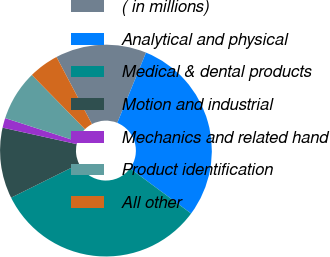Convert chart to OTSL. <chart><loc_0><loc_0><loc_500><loc_500><pie_chart><fcel>( in millions)<fcel>Analytical and physical<fcel>Medical & dental products<fcel>Motion and industrial<fcel>Mechanics and related hand<fcel>Product identification<fcel>All other<nl><fcel>13.91%<fcel>28.95%<fcel>32.54%<fcel>10.81%<fcel>1.49%<fcel>7.7%<fcel>4.6%<nl></chart> 